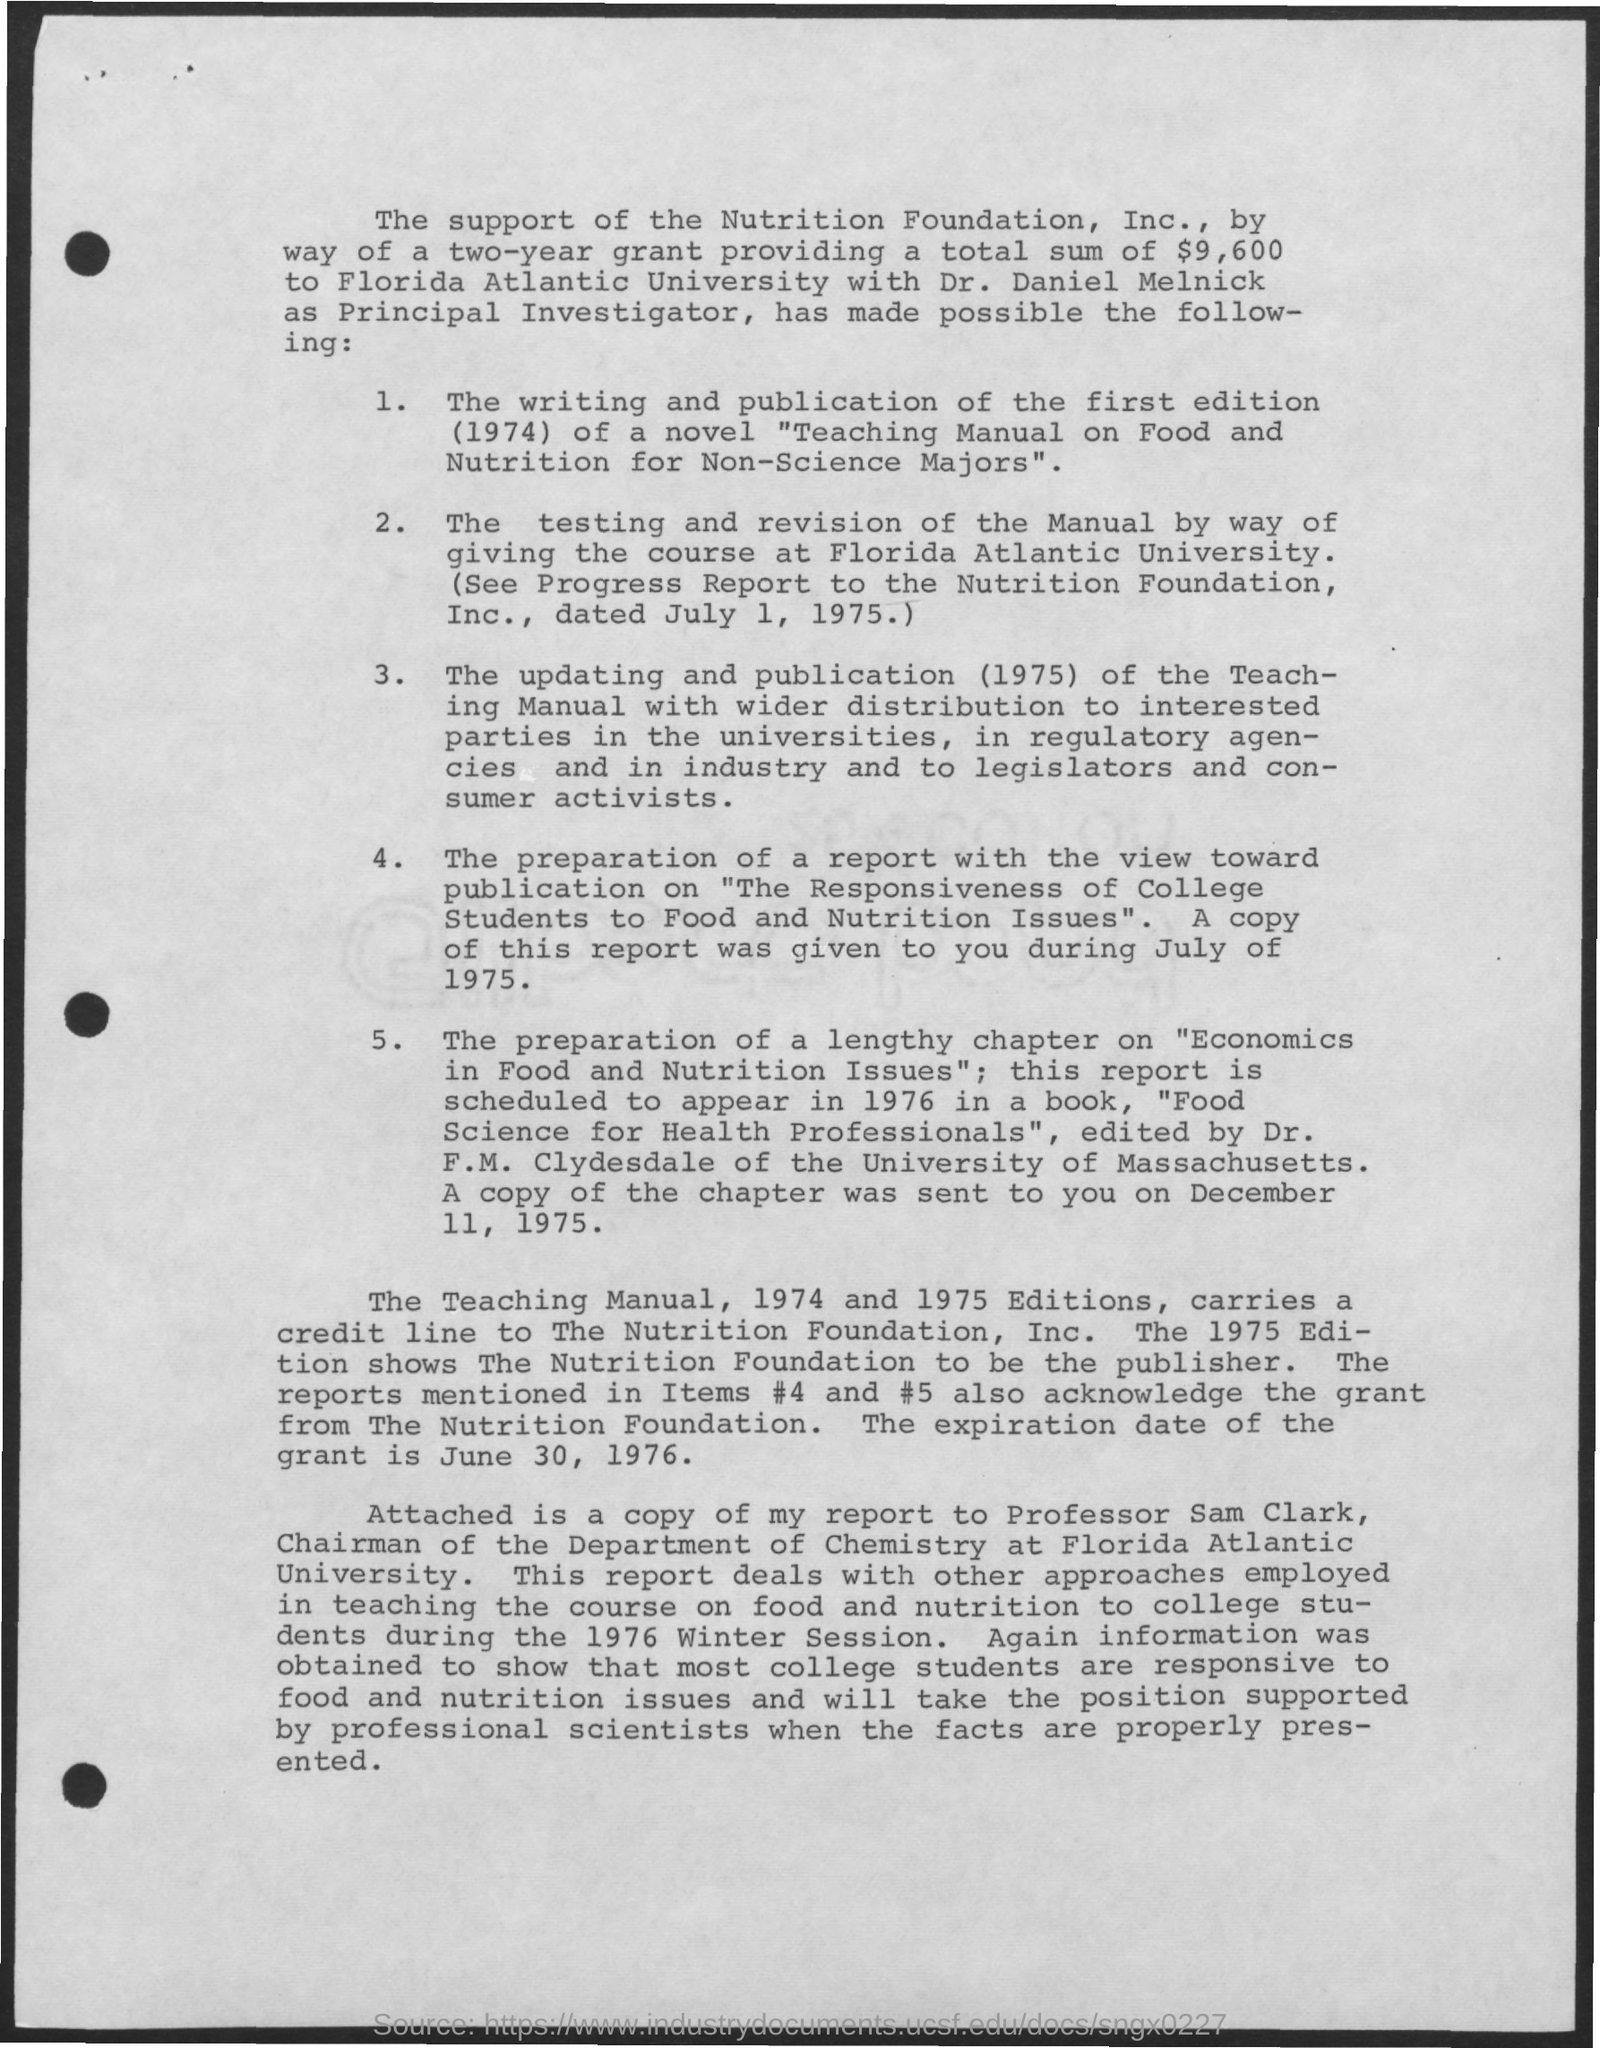What is the total sum of a two-year grant?
Provide a succinct answer. $9,600. Who is the Principal Investigator?
Your response must be concise. Dr. Daniel Melnick. When is the expiration date of the grant?
Your response must be concise. June 30, 1976. Who is the Chairman of the deparment of chemistry at Florida Atlantic University?
Your response must be concise. Professor Sam Clark. 